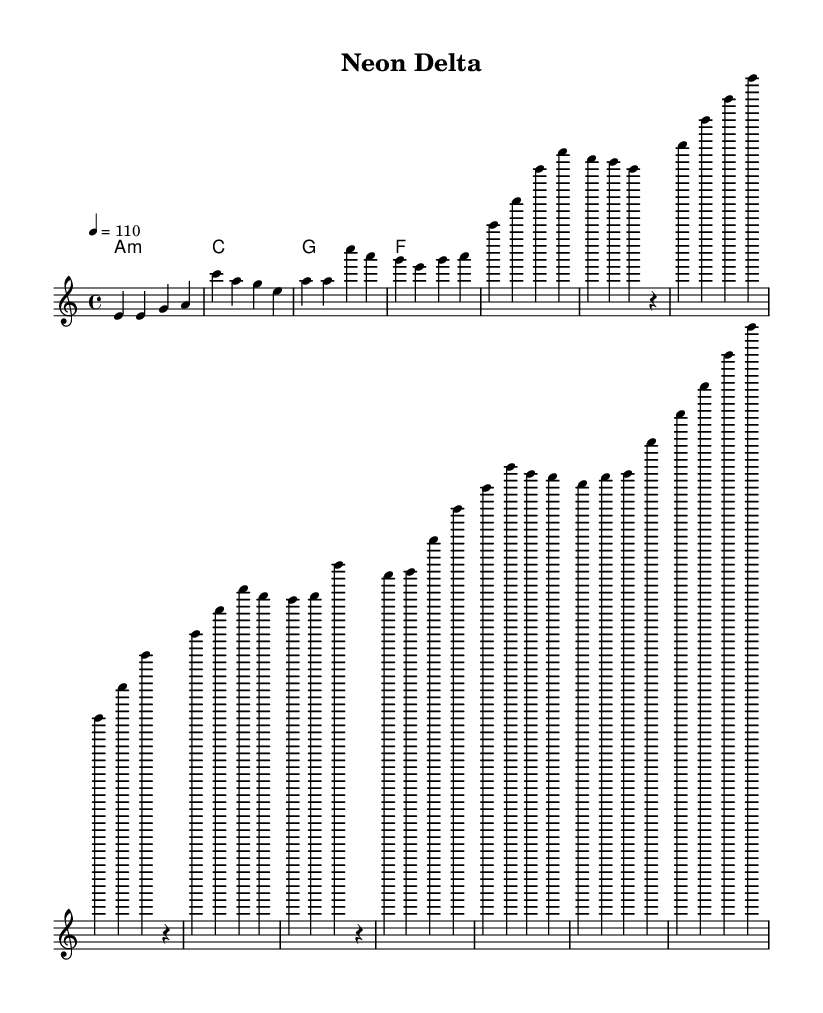What is the key signature of this music? The key signature is A minor, which has no sharps or flats, as indicated at the beginning of the score by the key signature next to the time signature.
Answer: A minor What is the time signature of the piece? The time signature is 4/4, which means there are four beats per measure and the quarter note gets one beat. This is shown next to the key signature at the start of the score.
Answer: 4/4 What is the tempo marking for this piece? The tempo marking is 110 beats per minute, indicated at the beginning of the score, showing that it should be played at this speed.
Answer: 110 What is the name of the song? The title of the song is "Neon Delta," as stated at the top of the sheet music in the header section.
Answer: Neon Delta How many measures are there in the song? To determine the number of measures, we can count each measure in the melody and harmonies section. There are a total of 12 measures in the song.
Answer: 12 What is the structure of the song? The structure includes an intro, a verse, a chorus, and a bridge, as inferred from the different sections outlined in the melody lines.
Answer: Intro, Verse, Chorus, Bridge Which chord is played at the beginning of the song? The first chord indicated in the harmonies section is A minor, which sets the tonality for the piece right from the start.
Answer: A minor 